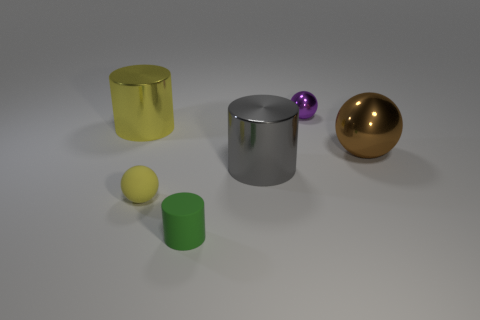Subtract all brown spheres. How many spheres are left? 2 Add 3 big shiny objects. How many objects exist? 9 Subtract 1 cylinders. How many cylinders are left? 2 Subtract 1 green cylinders. How many objects are left? 5 Subtract all cyan cylinders. Subtract all gray blocks. How many cylinders are left? 3 Subtract all brown cylinders. Subtract all large yellow cylinders. How many objects are left? 5 Add 6 yellow spheres. How many yellow spheres are left? 7 Add 2 matte blocks. How many matte blocks exist? 2 